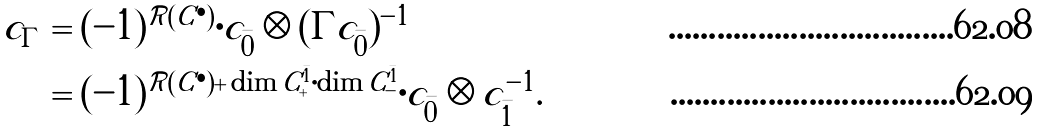<formula> <loc_0><loc_0><loc_500><loc_500>c _ { \Gamma } & = ( - 1 ) ^ { \mathcal { R } ( C ^ { \bullet } ) } \cdot c _ { \bar { 0 } } \otimes ( \Gamma c _ { \bar { 0 } } ) ^ { - 1 } \\ & = ( - 1 ) ^ { \mathcal { R } ( C ^ { \bullet } ) + \dim C ^ { \bar { 1 } } _ { + } \cdot \dim C ^ { \bar { 1 } } _ { - } } \cdot c _ { \bar { 0 } } \otimes c _ { \bar { 1 } } ^ { - 1 } .</formula> 